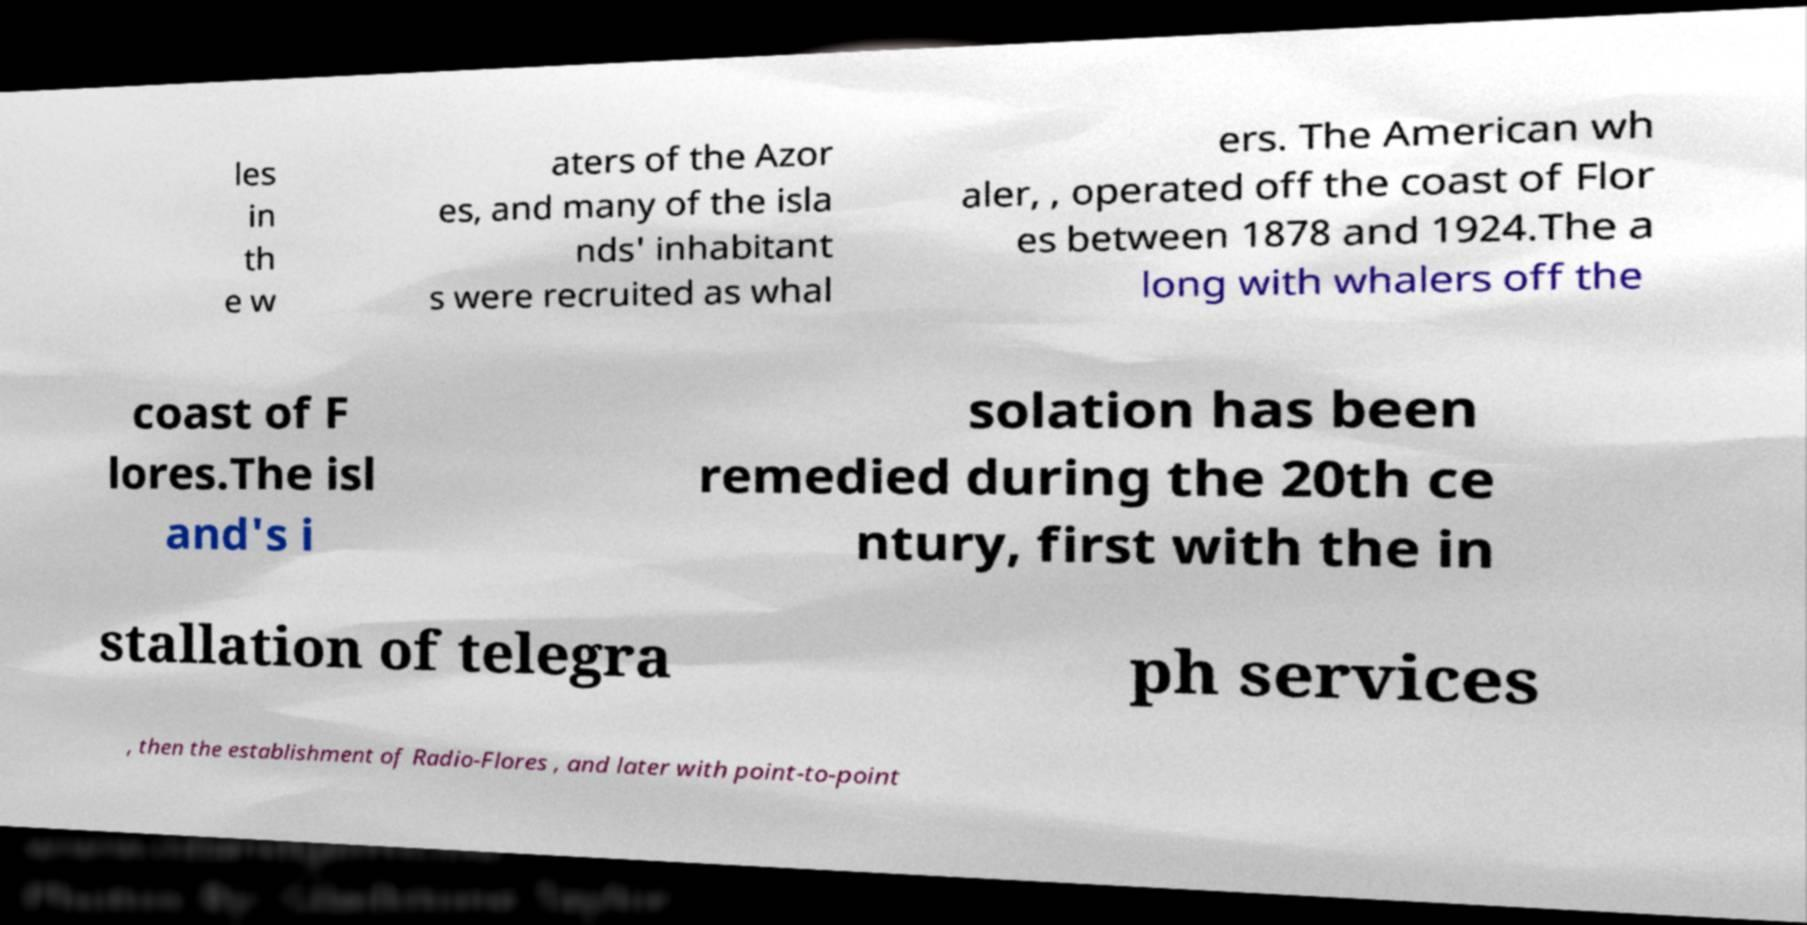For documentation purposes, I need the text within this image transcribed. Could you provide that? les in th e w aters of the Azor es, and many of the isla nds' inhabitant s were recruited as whal ers. The American wh aler, , operated off the coast of Flor es between 1878 and 1924.The a long with whalers off the coast of F lores.The isl and's i solation has been remedied during the 20th ce ntury, first with the in stallation of telegra ph services , then the establishment of Radio-Flores , and later with point-to-point 